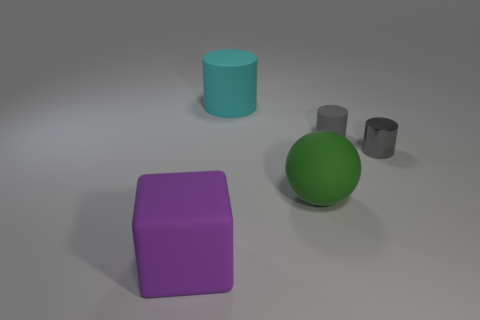Is there any other thing that has the same shape as the big purple object?
Offer a very short reply. No. Are there more big cyan cylinders than red cylinders?
Make the answer very short. Yes. Is there a ball that has the same color as the shiny object?
Your answer should be very brief. No. There is a thing that is to the left of the cyan matte thing; is its size the same as the small rubber cylinder?
Your response must be concise. No. Is the number of shiny things less than the number of big blue cubes?
Ensure brevity in your answer.  No. Are there any tiny cylinders made of the same material as the big purple object?
Provide a succinct answer. Yes. The purple thing to the left of the tiny rubber cylinder has what shape?
Offer a terse response. Cube. Do the big object behind the big green rubber object and the small metal object have the same color?
Make the answer very short. No. Are there fewer big cyan rubber cylinders that are in front of the large green matte object than small shiny things?
Provide a short and direct response. Yes. What is the color of the cylinder that is made of the same material as the big cyan object?
Offer a terse response. Gray. 